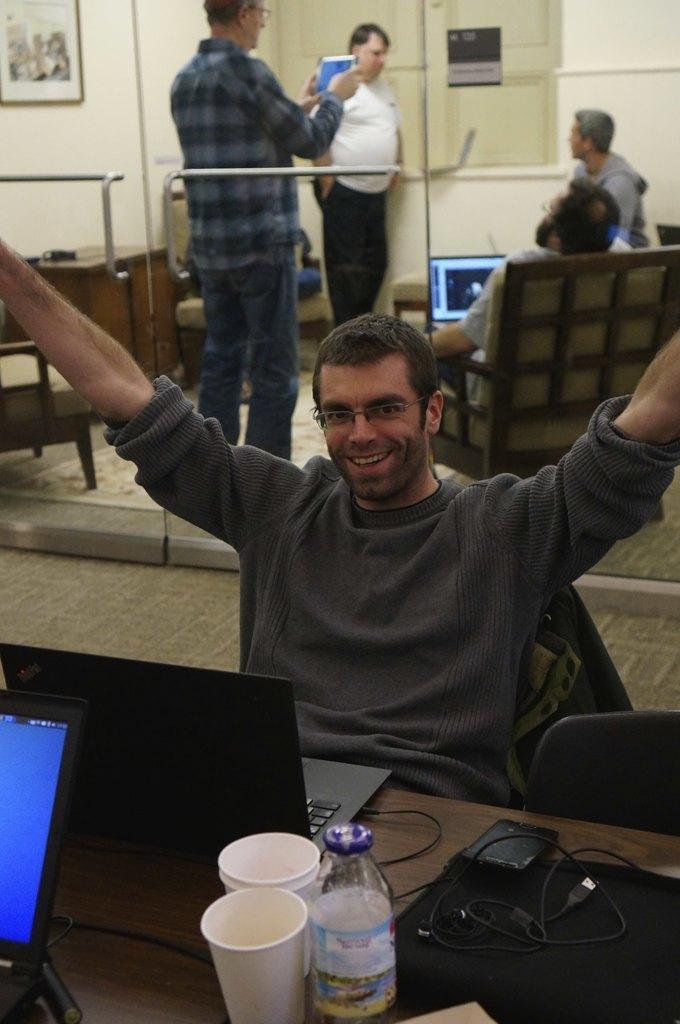In one or two sentences, can you explain what this image depicts? In this image we can see a person sitting on a chair beside a table containing the laptops, bottle, glasses, a wallet and some wires. On the backside we can see some people. In that a person sitting on the chair is holding a laptop and the other is holding a display screen. We can also see a table, chair and a photo frame on a wall. 